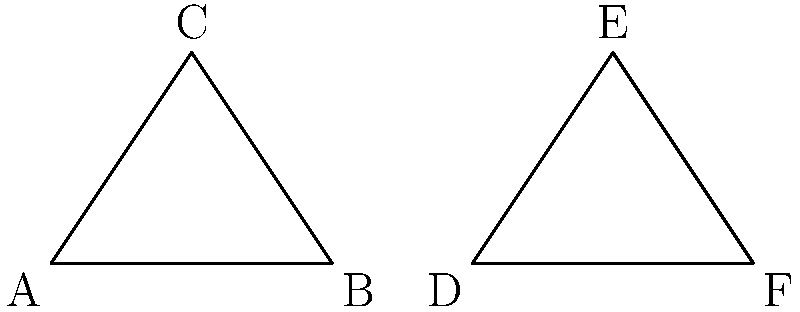In the stained glass window of a cathedral, two triangular panels are depicted as shown above. Given that $\overline{AB} \cong \overline{DF}$ and $\angle BAC \cong \angle FDE$, what additional condition is necessary to prove that triangle ABC is congruent to triangle DEF? To prove that two triangles are congruent, we need to use one of the congruence criteria. Let's approach this step-by-step:

1. We are given that $\overline{AB} \cong \overline{DF}$. This means we have one pair of congruent sides.

2. We are also given that $\angle BAC \cong \angle FDE$. This means we have one pair of congruent angles.

3. To prove congruence, we need to use one of these criteria:
   - Side-Angle-Side (SAS)
   - Angle-Side-Angle (ASA)
   - Side-Side-Side (SSS)
   - Angle-Angle-Side (AAS)

4. With the given information, we're closest to fulfilling the SAS criterion.

5. For SAS, we need:
   - Two pairs of congruent sides
   - The included angle between these sides to be congruent

6. We already have one pair of congruent sides ($\overline{AB} \cong \overline{DF}$) and the angle adjacent to this side ($\angle BAC \cong \angle FDE$).

7. Therefore, the additional condition needed is that the other side adjacent to the given angle must be congruent, i.e., $\overline{AC} \cong \overline{DE}$.

This would complete the SAS criterion, proving the triangles congruent.
Answer: $\overline{AC} \cong \overline{DE}$ 